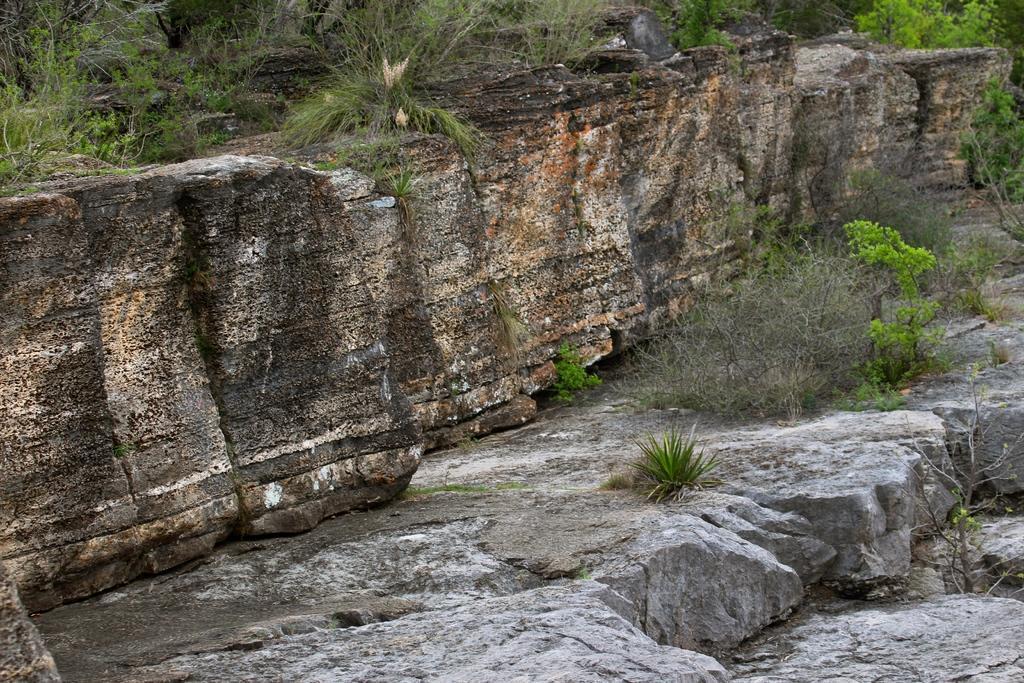Please provide a concise description of this image. In this image, we can see a wall, we can see some plants and trees. 